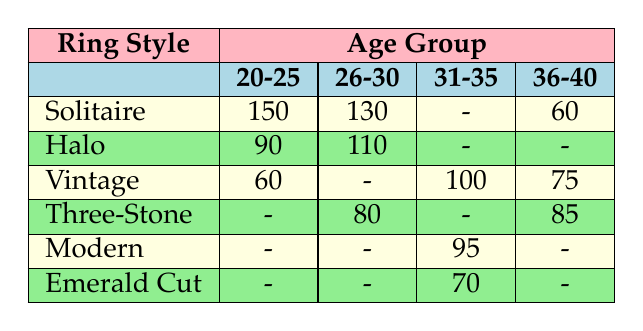What is the preference count for Solitaire rings among those aged 20-25? The table shows that the preference count for Solitaire rings in the age group of 20-25 is 150.
Answer: 150 Which ring style is preferred the most by people aged 26-30? For the age group of 26-30, the table shows the preference counts for Halo as 110 and Solitaire as 130. Since 130 is higher, Solitaire is the most preferred ring style.
Answer: Solitaire How many age groups in the table show a preference for Vintage rings? The table shows Vintage rings are preferred by age groups 20-25 (60), 31-35 (100), and 36-40 (75). This gives us a total of three distinct age groups.
Answer: 3 What is the total preference count for Halo rings across all age groups? To find the total for Halo rings, we look at the counts for each age group: 90 (20-25) + 110 (26-30) + 0 (31-35) + 0 (36-40) = 200. Thus, the total preference count for Halo is 200.
Answer: 200 Is it true that the Three-Stone ring style has the highest preference count in any age group? In the table, Three-Stone has 85 preferences in the 36-40 age group, while other styles like Solitaire have higher counts (150 in 20-25 and 130 in 26-30). Therefore, this statement is false.
Answer: No What is the average preference count for all ring styles within the age group 31-35? The preference counts for the age group 31-35 are for Vintage (100), Modern (95), and Emerald Cut (70). To find the average, we sum these counts: 100 + 95 + 70 = 265. Then we divide by the number of styles (3), resulting in an average of 265/3 = approximately 88.33.
Answer: 88.33 Which ring style has the lowest overall preference across all age groups? Analyzing the counts, the styles with preferences are: Solitaire (340), Halo (200), Vintage (235), Three-Stone (165), Modern (95), and Emerald Cut (70). Comparing them, Emerald Cut has the lowest preference count of 70.
Answer: Emerald Cut How many age groups prefer the Vintage ring style more than the Halo ring style? From the table, for age 20-25, Vintage (60) is less than Halo (90). For 31-35, Vintage (100) is greater than the non-preferred Halo (0). For 36-40, Vintage (75) is also less than Halo (0), thus only one age group (31-35) prefers Vintage over Halo.
Answer: 1 In which age group does the Vintage ring style have the highest preference count? Looking through the age groups, Vintage has 60 (20-25), 100 (31-35), and 75 (36-40). The highest preference count is 100 in the 31-35 age group.
Answer: 31-35 